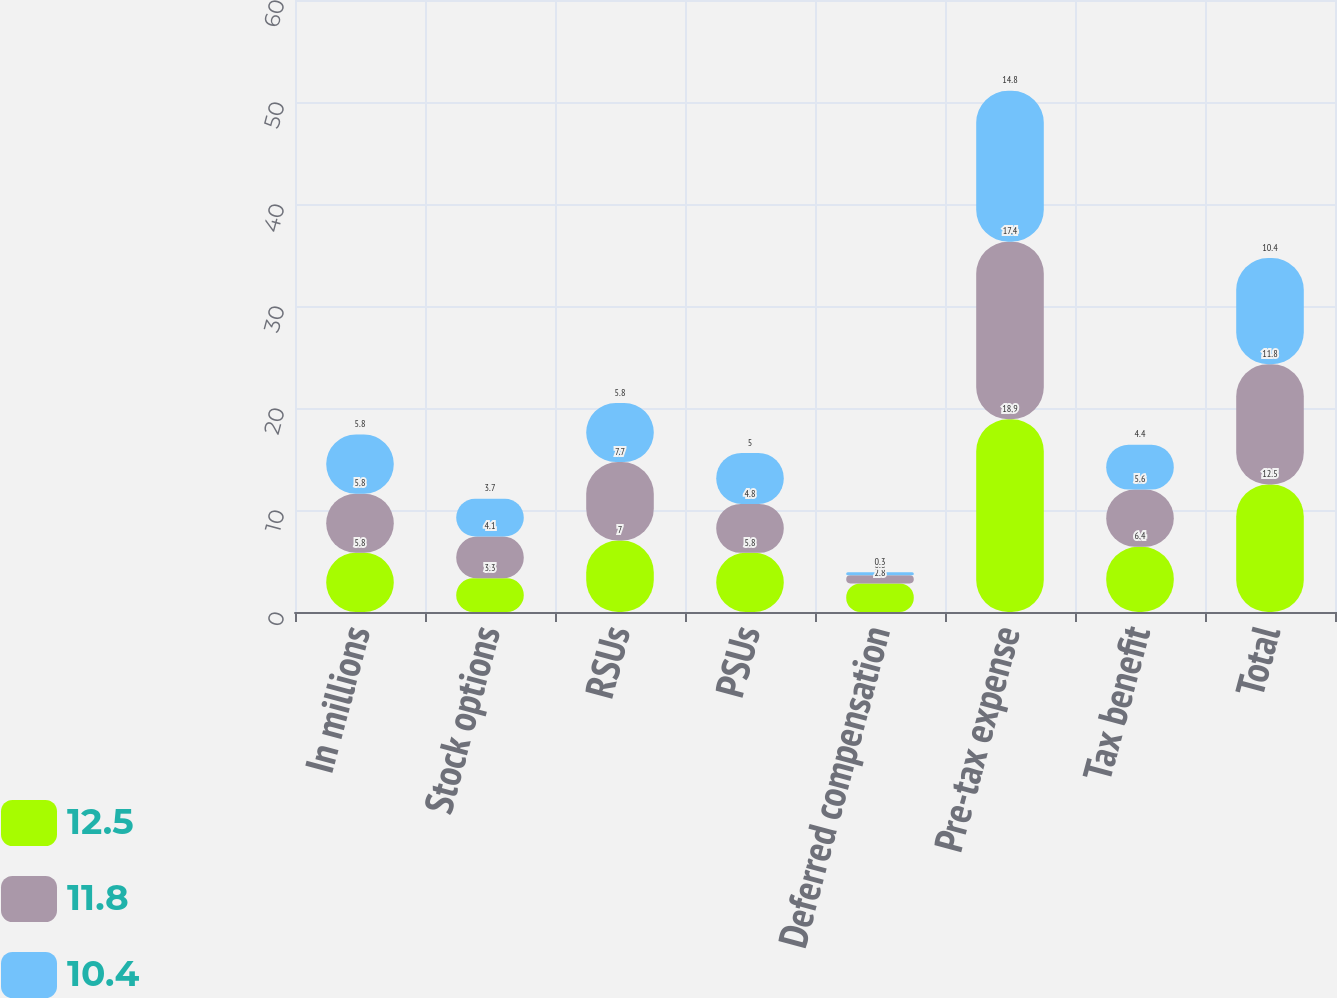Convert chart to OTSL. <chart><loc_0><loc_0><loc_500><loc_500><stacked_bar_chart><ecel><fcel>In millions<fcel>Stock options<fcel>RSUs<fcel>PSUs<fcel>Deferred compensation<fcel>Pre-tax expense<fcel>Tax benefit<fcel>Total<nl><fcel>12.5<fcel>5.8<fcel>3.3<fcel>7<fcel>5.8<fcel>2.8<fcel>18.9<fcel>6.4<fcel>12.5<nl><fcel>11.8<fcel>5.8<fcel>4.1<fcel>7.7<fcel>4.8<fcel>0.8<fcel>17.4<fcel>5.6<fcel>11.8<nl><fcel>10.4<fcel>5.8<fcel>3.7<fcel>5.8<fcel>5<fcel>0.3<fcel>14.8<fcel>4.4<fcel>10.4<nl></chart> 